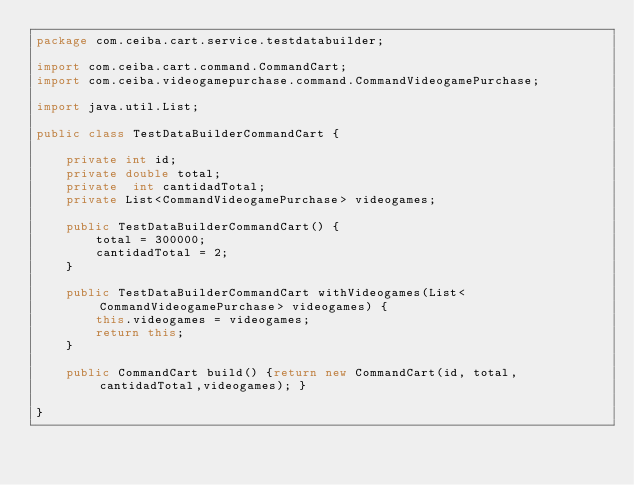Convert code to text. <code><loc_0><loc_0><loc_500><loc_500><_Java_>package com.ceiba.cart.service.testdatabuilder;

import com.ceiba.cart.command.CommandCart;
import com.ceiba.videogamepurchase.command.CommandVideogamePurchase;

import java.util.List;

public class TestDataBuilderCommandCart {

    private int id;
    private double total;
    private  int cantidadTotal;
    private List<CommandVideogamePurchase> videogames;

    public TestDataBuilderCommandCart() {
        total = 300000;
        cantidadTotal = 2;
    }

    public TestDataBuilderCommandCart withVideogames(List<CommandVideogamePurchase> videogames) {
        this.videogames = videogames;
        return this;
    }

    public CommandCart build() {return new CommandCart(id, total, cantidadTotal,videogames); }

}
</code> 